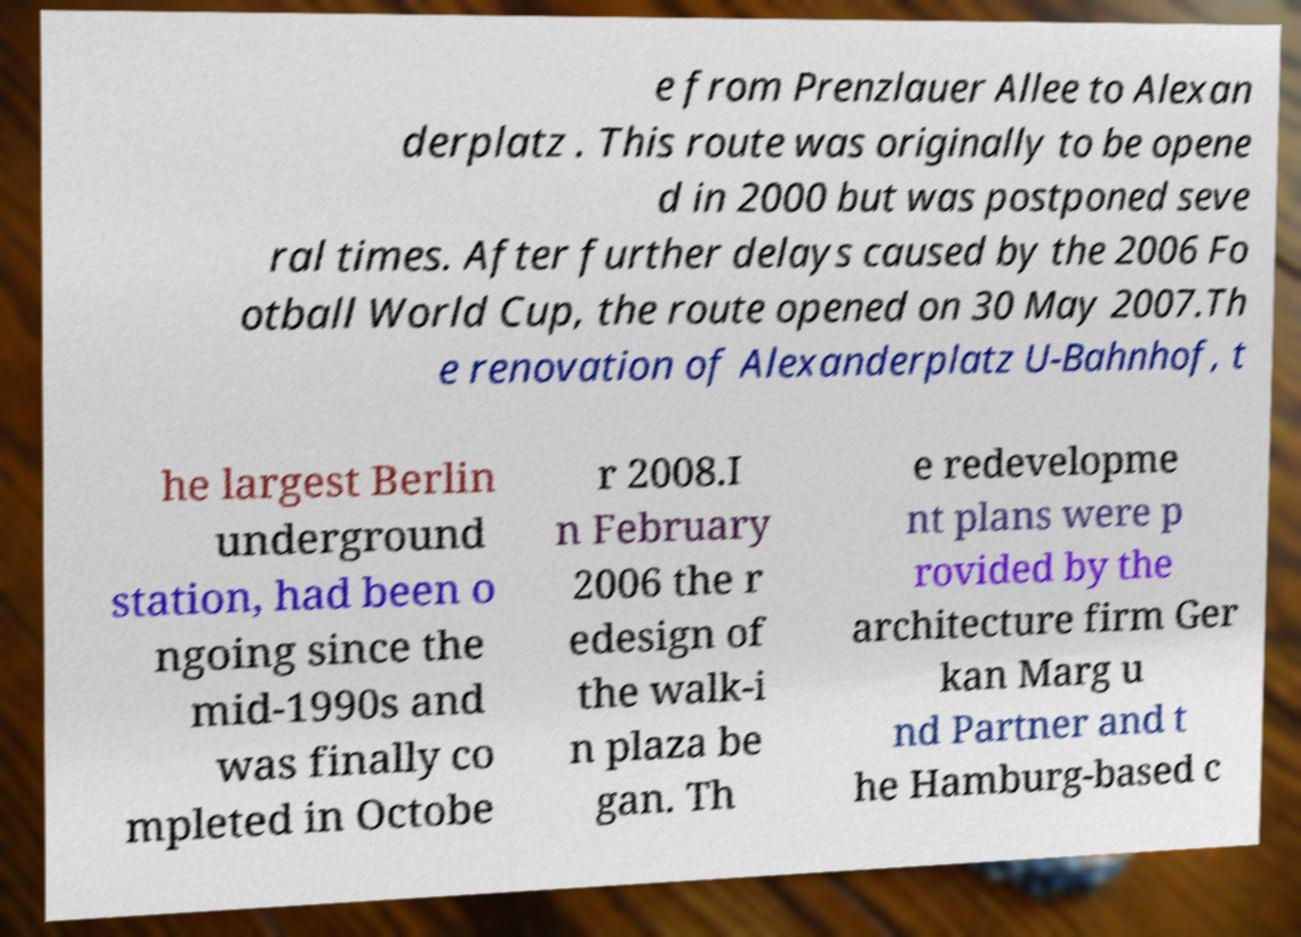Could you extract and type out the text from this image? e from Prenzlauer Allee to Alexan derplatz . This route was originally to be opene d in 2000 but was postponed seve ral times. After further delays caused by the 2006 Fo otball World Cup, the route opened on 30 May 2007.Th e renovation of Alexanderplatz U-Bahnhof, t he largest Berlin underground station, had been o ngoing since the mid-1990s and was finally co mpleted in Octobe r 2008.I n February 2006 the r edesign of the walk-i n plaza be gan. Th e redevelopme nt plans were p rovided by the architecture firm Ger kan Marg u nd Partner and t he Hamburg-based c 